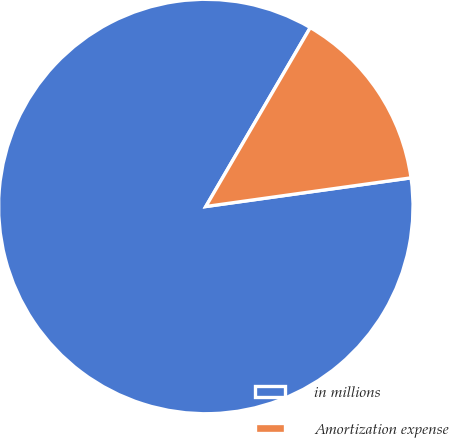<chart> <loc_0><loc_0><loc_500><loc_500><pie_chart><fcel>in millions<fcel>Amortization expense<nl><fcel>85.62%<fcel>14.38%<nl></chart> 